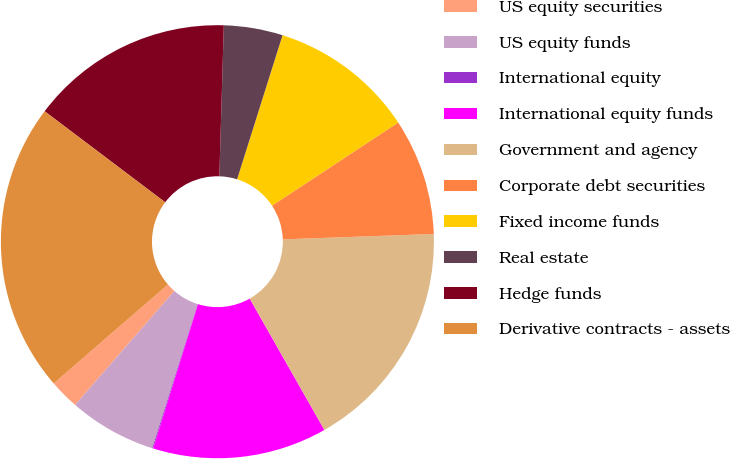Convert chart. <chart><loc_0><loc_0><loc_500><loc_500><pie_chart><fcel>US equity securities<fcel>US equity funds<fcel>International equity<fcel>International equity funds<fcel>Government and agency<fcel>Corporate debt securities<fcel>Fixed income funds<fcel>Real estate<fcel>Hedge funds<fcel>Derivative contracts - assets<nl><fcel>2.23%<fcel>6.55%<fcel>0.07%<fcel>13.02%<fcel>17.34%<fcel>8.71%<fcel>10.86%<fcel>4.39%<fcel>15.18%<fcel>21.65%<nl></chart> 